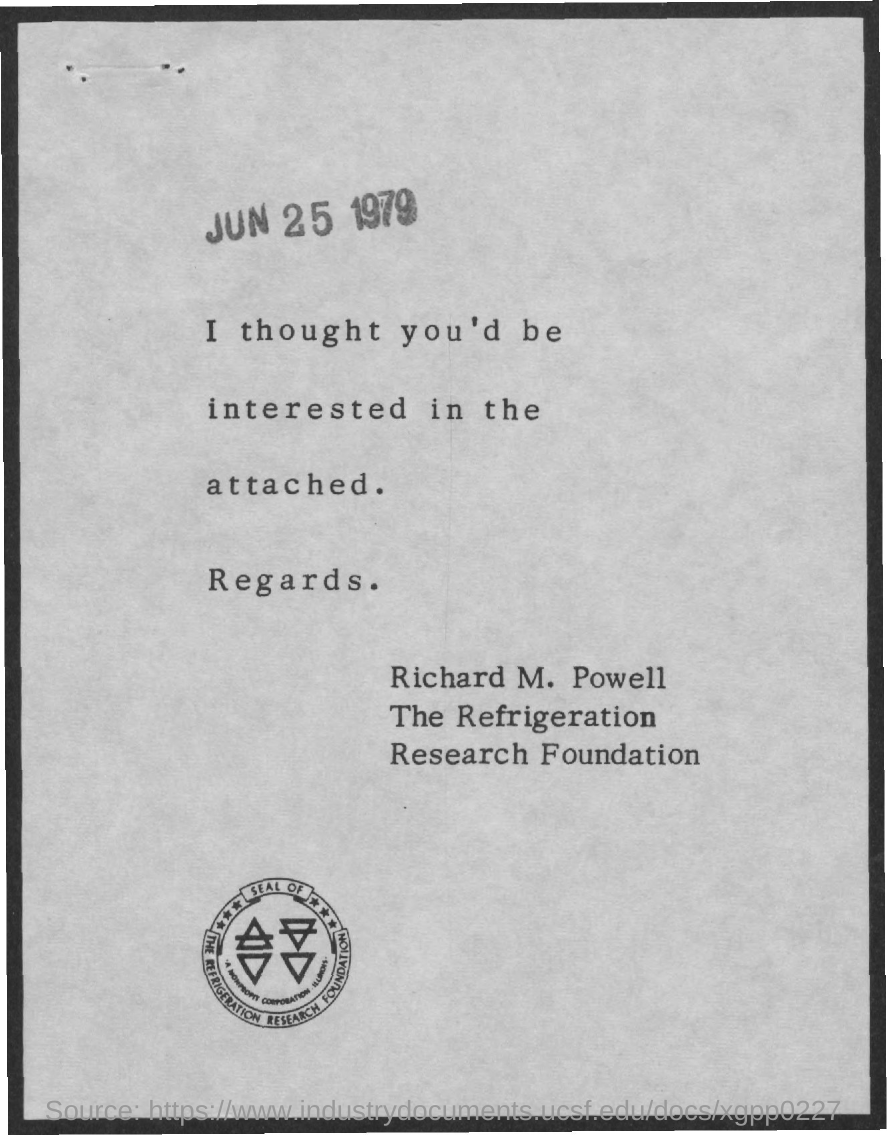What is the document dated?
Provide a succinct answer. JUN 25 1979. Which company seal is given here?
Give a very brief answer. THE REFRIGERATION RESEARCH FOUNDATION. 